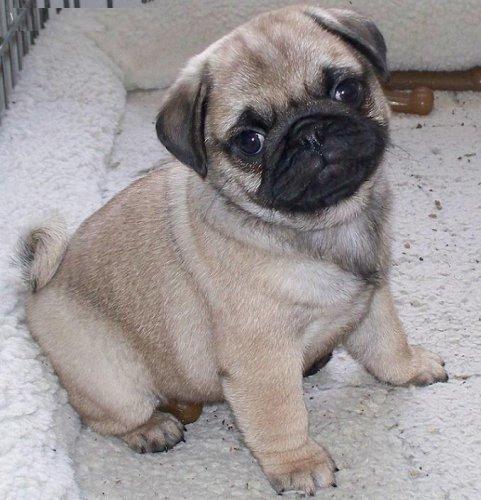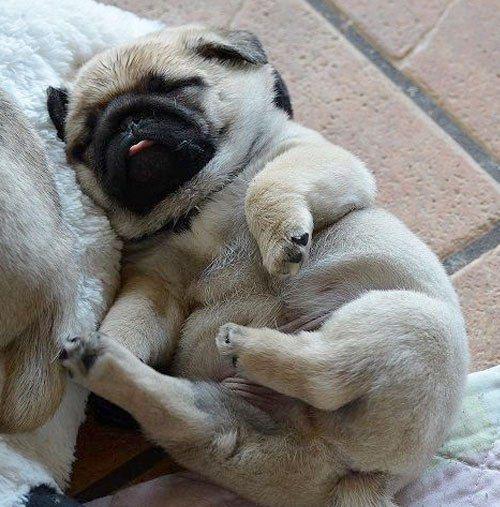The first image is the image on the left, the second image is the image on the right. Given the left and right images, does the statement "An image shows two beige pug pups and a white spotted pug pup sleeping on top of a sleeping human baby." hold true? Answer yes or no. No. The first image is the image on the left, the second image is the image on the right. Analyze the images presented: Is the assertion "The dogs in one of the images are sleeping on a baby." valid? Answer yes or no. No. 